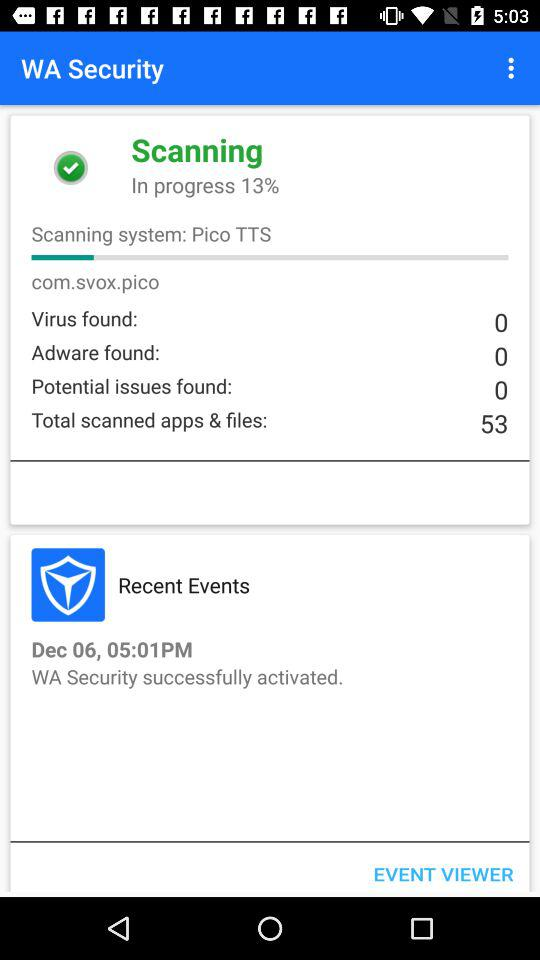How many viruses are found? There are 0 viruses. 